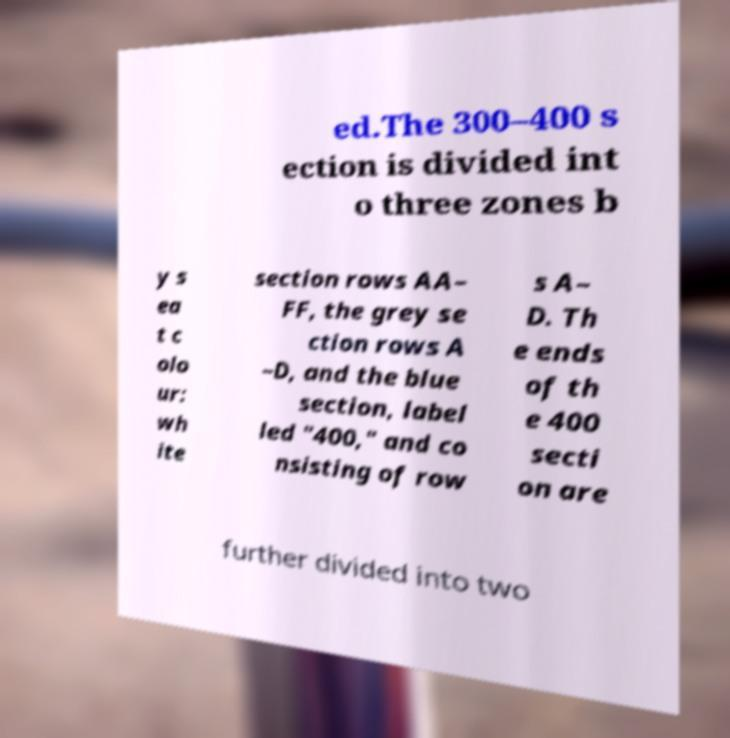Please identify and transcribe the text found in this image. ed.The 300–400 s ection is divided int o three zones b y s ea t c olo ur: wh ite section rows AA– FF, the grey se ction rows A –D, and the blue section, label led "400," and co nsisting of row s A– D. Th e ends of th e 400 secti on are further divided into two 